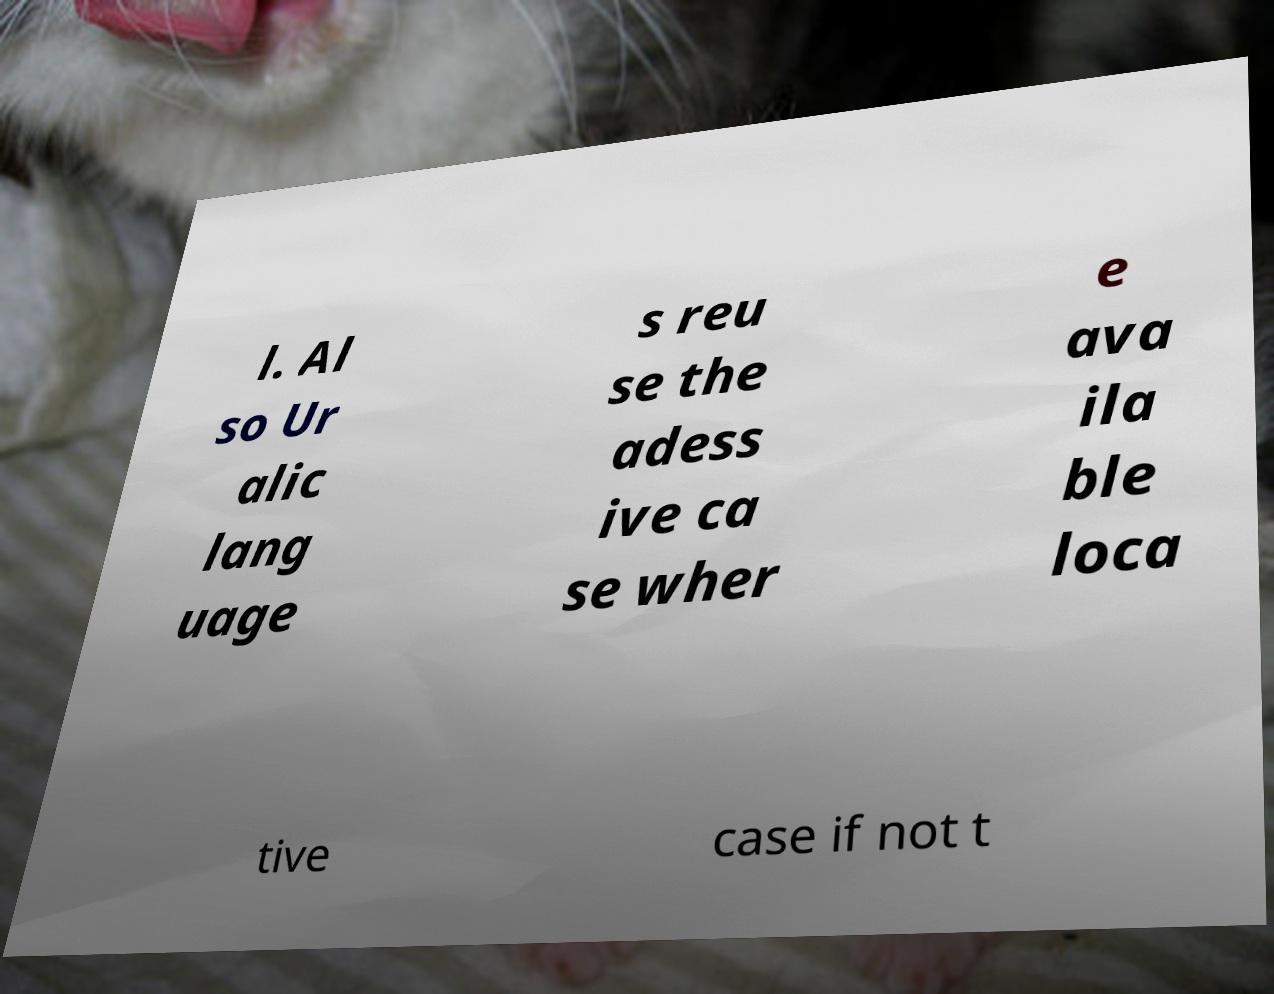For documentation purposes, I need the text within this image transcribed. Could you provide that? l. Al so Ur alic lang uage s reu se the adess ive ca se wher e ava ila ble loca tive case if not t 